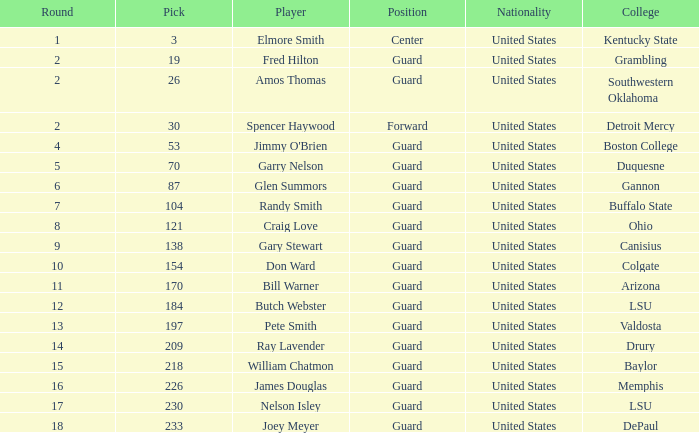WHAT ROUND HAS A GUARD POSITION AT OHIO COLLEGE? 8.0. 